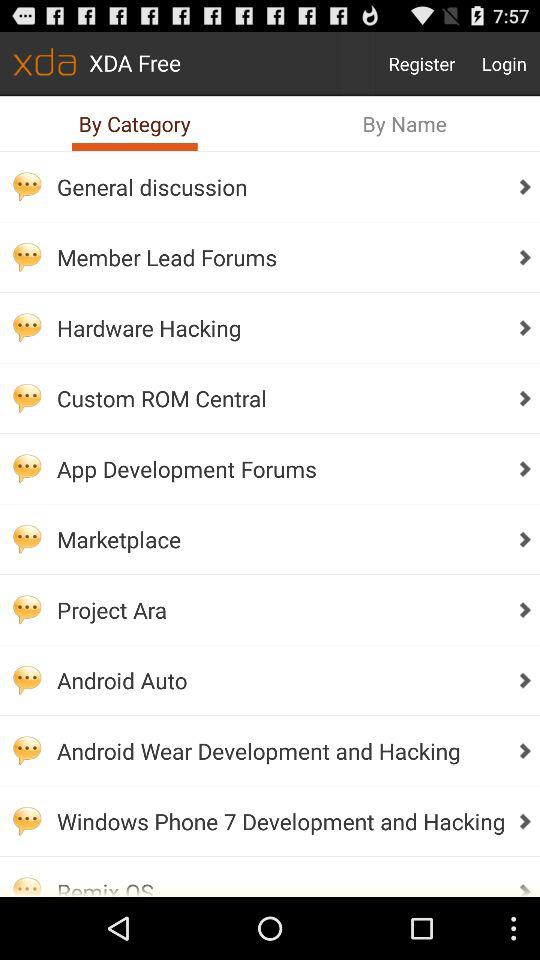Which tab is selected? The selected tab is "By Category". 